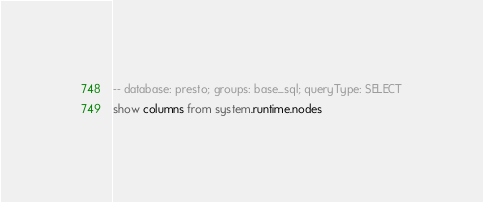Convert code to text. <code><loc_0><loc_0><loc_500><loc_500><_SQL_>-- database: presto; groups: base_sql; queryType: SELECT
show columns from system.runtime.nodes
</code> 